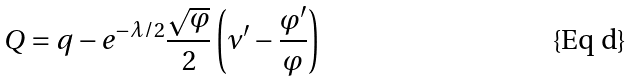Convert formula to latex. <formula><loc_0><loc_0><loc_500><loc_500>Q = q - e ^ { - \lambda / 2 } \frac { \sqrt { \varphi } } { 2 } \left ( \nu ^ { \prime } - \frac { \varphi ^ { \prime } } { \varphi } \right )</formula> 